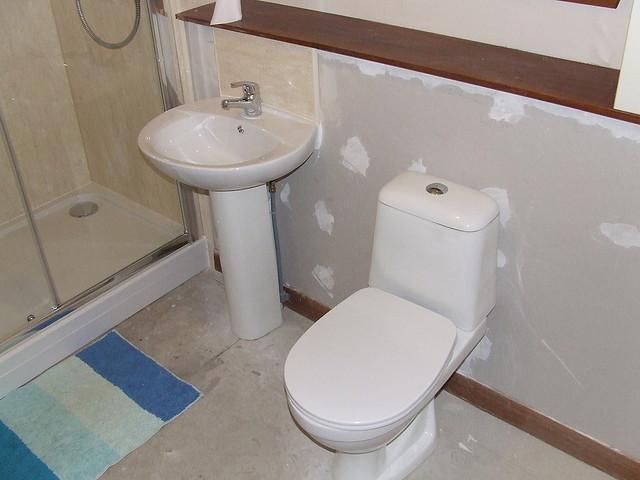How many shades of blue are in the bath mat?
Give a very brief answer. 3. How many people in black pants?
Give a very brief answer. 0. 